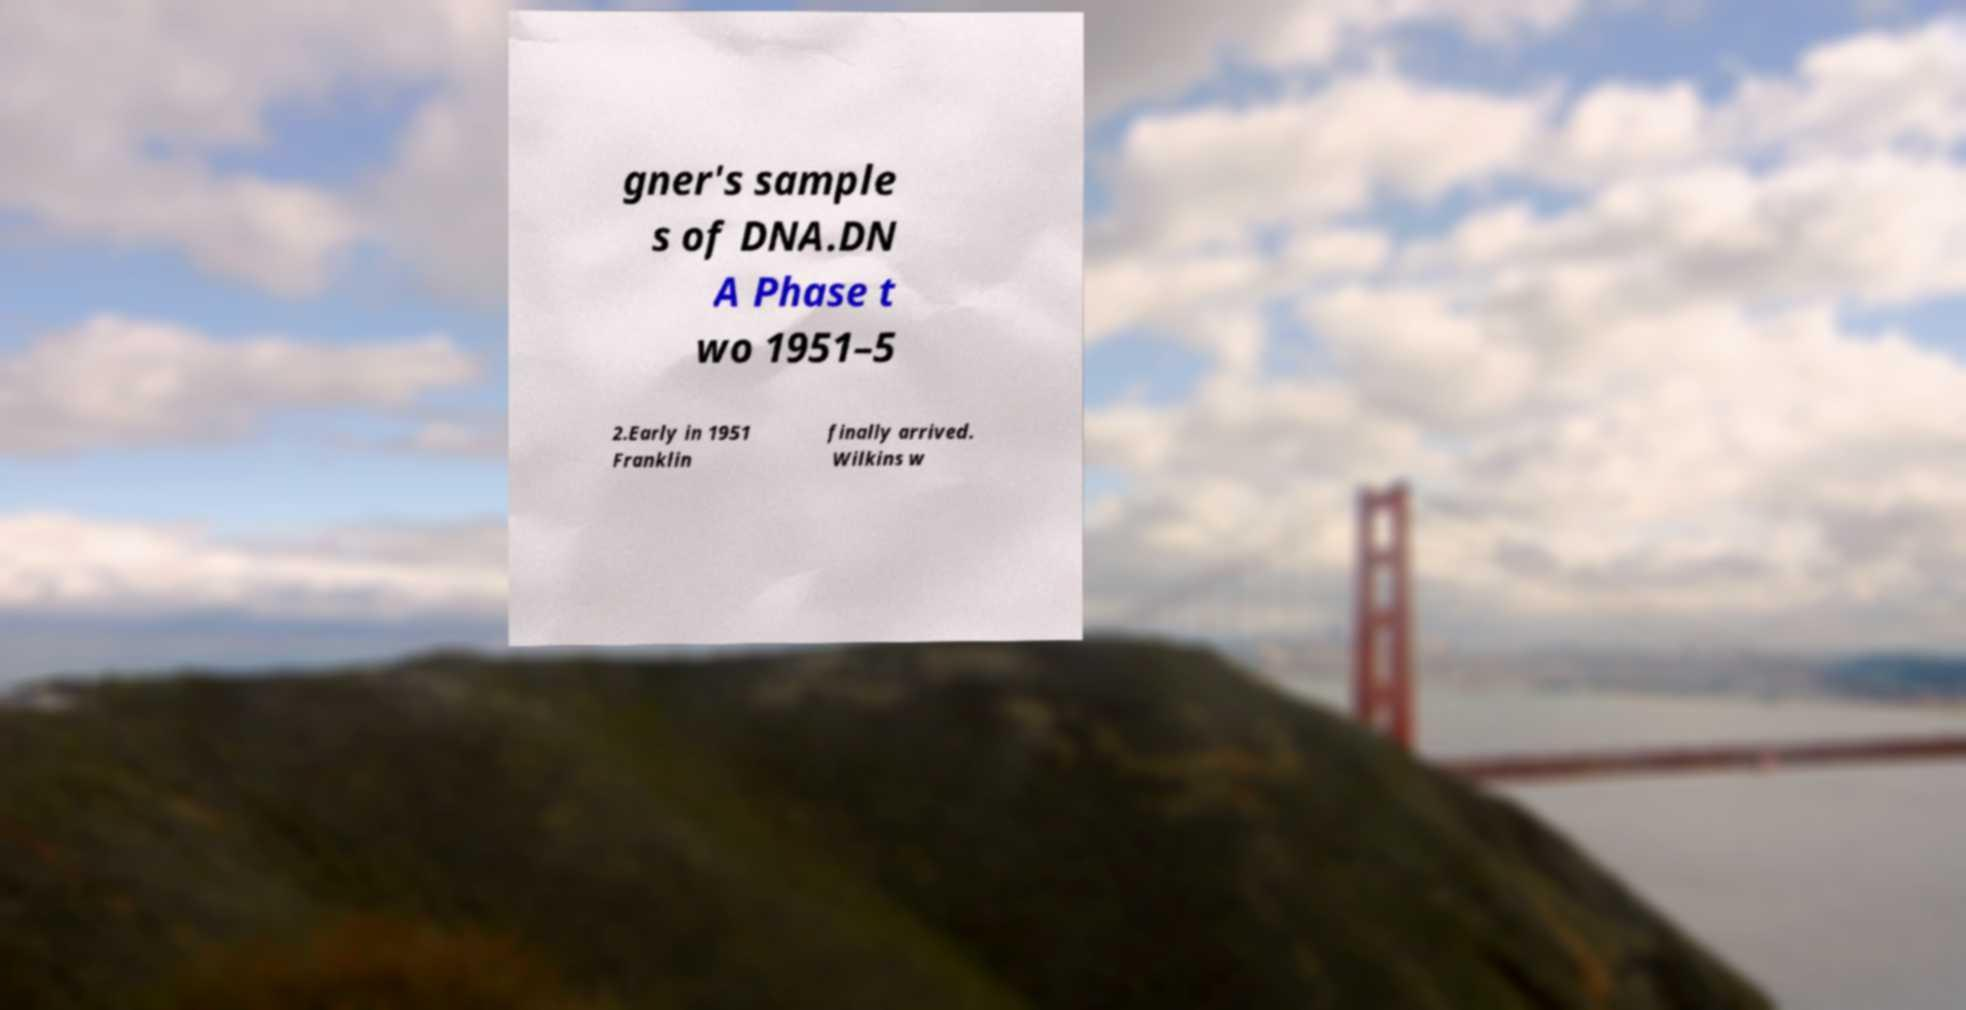Can you accurately transcribe the text from the provided image for me? gner's sample s of DNA.DN A Phase t wo 1951–5 2.Early in 1951 Franklin finally arrived. Wilkins w 